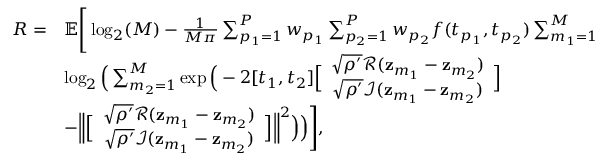Convert formula to latex. <formula><loc_0><loc_0><loc_500><loc_500>\begin{array} { r l } { R = } & { \mathbb { E } \left [ \log _ { 2 } ( M ) - \frac { 1 } { M \pi } \sum _ { p _ { 1 } = 1 } ^ { P } w _ { p _ { 1 } } \sum _ { p _ { 2 } = 1 } ^ { P } w _ { p _ { 2 } } f ( t _ { p _ { 1 } } , t _ { p _ { 2 } } ) \sum _ { m _ { 1 } = 1 } ^ { M } } \\ & { \log _ { 2 } \left ( \sum _ { m _ { 2 } = 1 } ^ { M } \exp \left ( - 2 [ t _ { 1 } , t _ { 2 } ] \left [ \begin{array} { c } { \sqrt { \rho ^ { \prime } } \mathcal { R } ( z _ { m _ { 1 } } - z _ { m _ { 2 } } ) } \\ { \sqrt { \rho ^ { \prime } } \mathcal { I } ( z _ { m _ { 1 } } - z _ { m _ { 2 } } ) } \end{array} \right ] } \\ & { - \left \| \left [ \begin{array} { c } { \sqrt { \rho ^ { \prime } } \mathcal { R } ( z _ { m _ { 1 } } - z _ { m _ { 2 } } ) } \\ { \sqrt { \rho ^ { \prime } } \mathcal { I } ( z _ { m _ { 1 } } - z _ { m _ { 2 } } ) } \end{array} \right ] \right \| ^ { 2 } \right ) \right ) \right ] , } \end{array}</formula> 